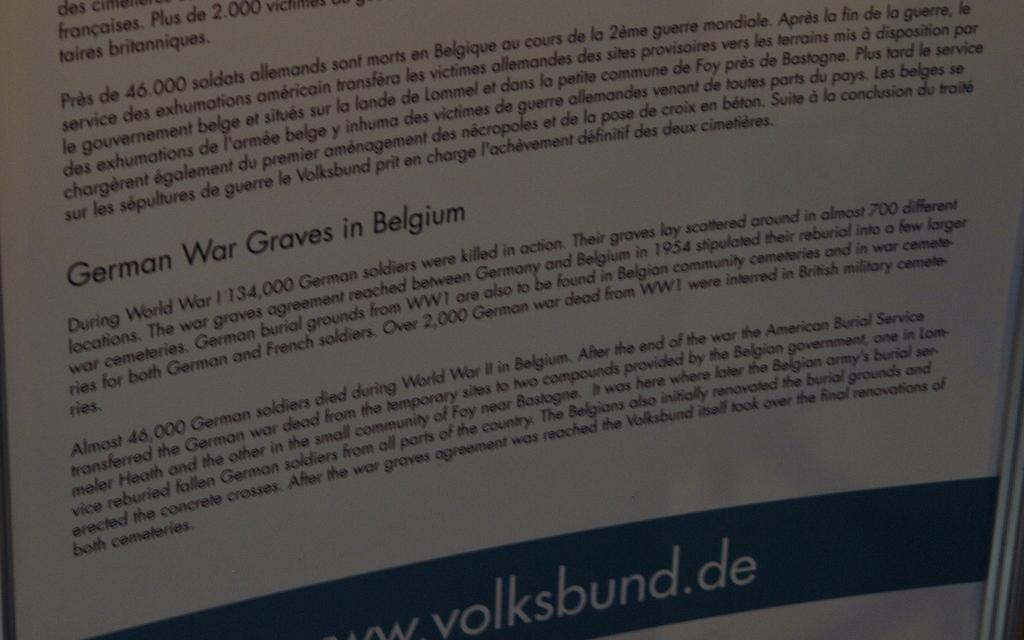<image>
Summarize the visual content of the image. A piece of paper listing where the German war graves in Belgium are located. 